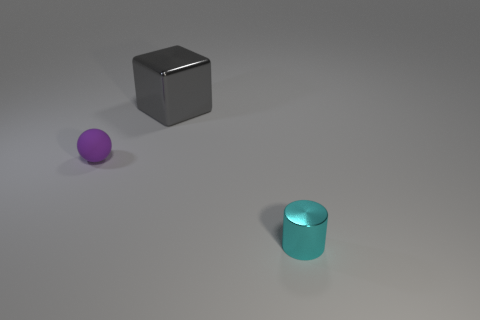What is the shape of the large thing?
Provide a short and direct response. Cube. What number of things are tiny things that are left of the cylinder or rubber balls?
Provide a succinct answer. 1. Is the material of the tiny purple sphere the same as the thing that is behind the rubber sphere?
Your answer should be compact. No. What is the color of the tiny metal thing?
Make the answer very short. Cyan. What is the color of the metal thing left of the metal thing that is in front of the metallic thing that is behind the metal cylinder?
Provide a succinct answer. Gray. There is a big shiny thing; does it have the same shape as the small thing that is in front of the purple object?
Keep it short and to the point. No. There is a thing that is behind the small cylinder and in front of the big shiny cube; what is its color?
Offer a terse response. Purple. There is a small object on the right side of the large gray metallic block; is there a gray cube that is behind it?
Provide a succinct answer. Yes. What number of things are things that are right of the tiny purple thing or things in front of the large gray shiny object?
Your answer should be very brief. 3. What number of objects are either yellow objects or tiny things behind the tiny cyan cylinder?
Offer a terse response. 1. 